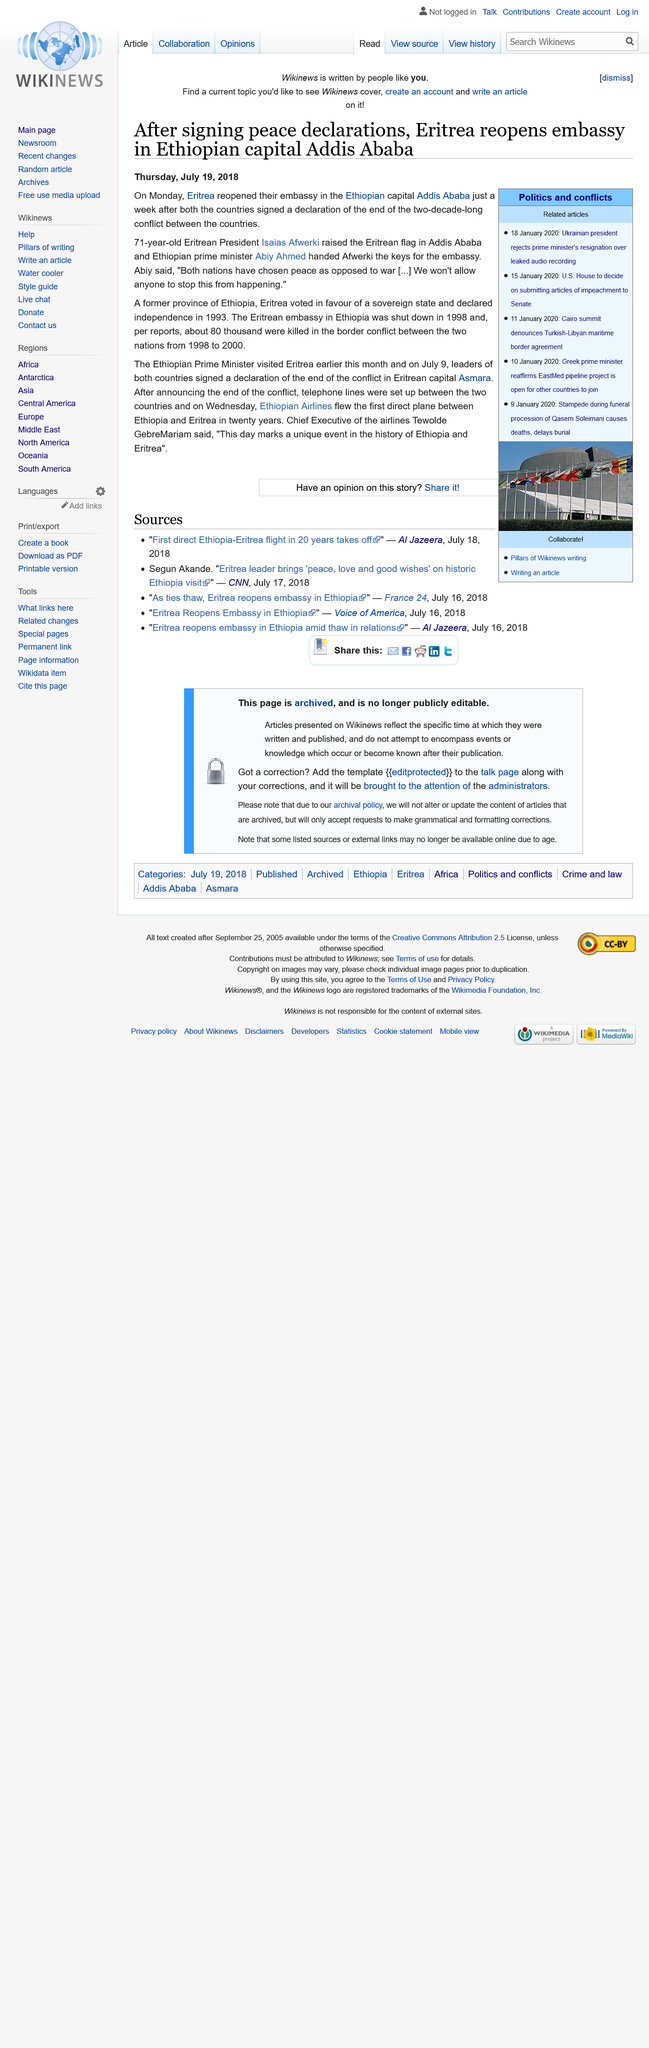Point out several critical features in this image. Eritrea gained its independence from Ethiopia in 1993. Eritrea was formerly a province of Ethiopia. The Eritrean embassy in Ethiopia was shut down in the year 1998. 